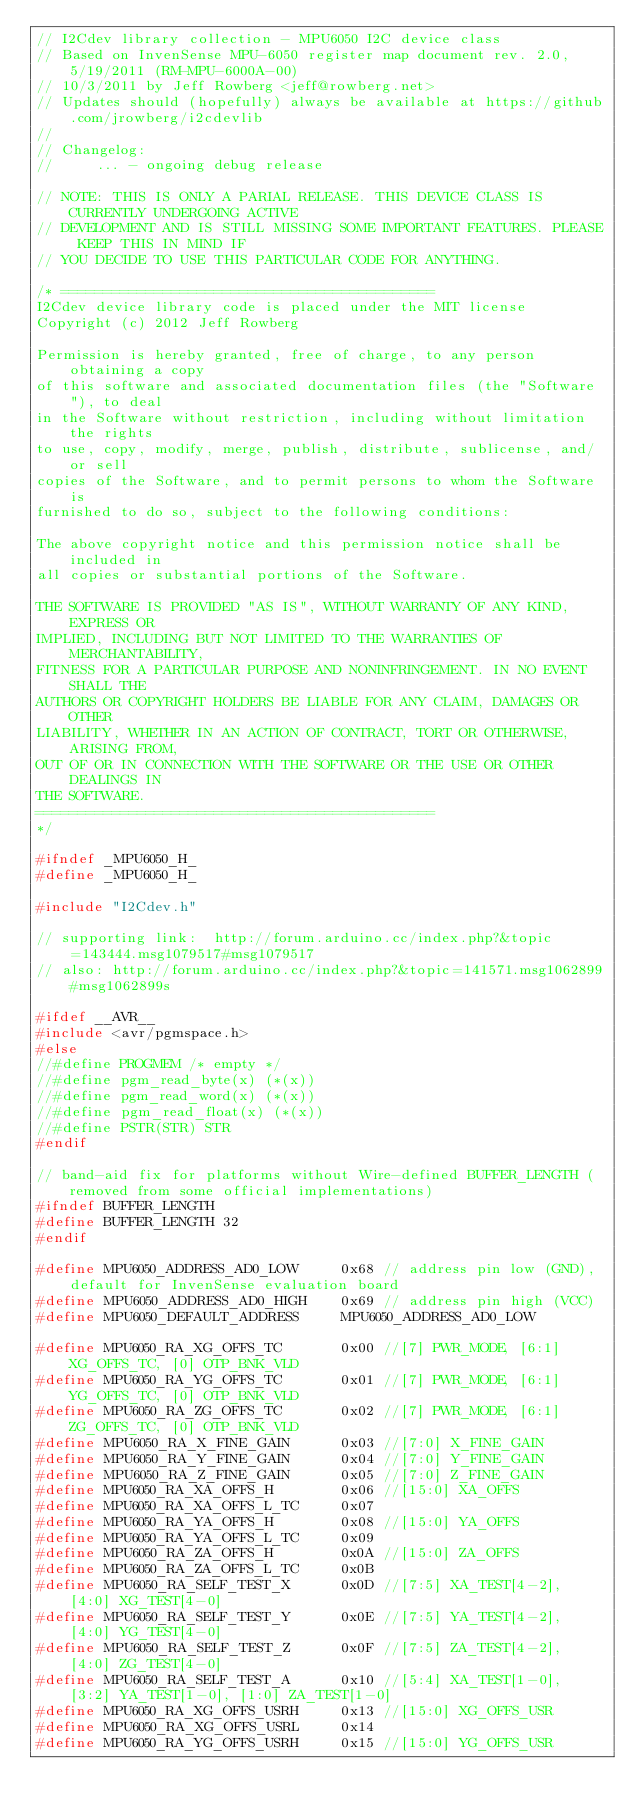<code> <loc_0><loc_0><loc_500><loc_500><_C_>// I2Cdev library collection - MPU6050 I2C device class
// Based on InvenSense MPU-6050 register map document rev. 2.0, 5/19/2011 (RM-MPU-6000A-00)
// 10/3/2011 by Jeff Rowberg <jeff@rowberg.net>
// Updates should (hopefully) always be available at https://github.com/jrowberg/i2cdevlib
//
// Changelog:
//     ... - ongoing debug release

// NOTE: THIS IS ONLY A PARIAL RELEASE. THIS DEVICE CLASS IS CURRENTLY UNDERGOING ACTIVE
// DEVELOPMENT AND IS STILL MISSING SOME IMPORTANT FEATURES. PLEASE KEEP THIS IN MIND IF
// YOU DECIDE TO USE THIS PARTICULAR CODE FOR ANYTHING.

/* ============================================
I2Cdev device library code is placed under the MIT license
Copyright (c) 2012 Jeff Rowberg

Permission is hereby granted, free of charge, to any person obtaining a copy
of this software and associated documentation files (the "Software"), to deal
in the Software without restriction, including without limitation the rights
to use, copy, modify, merge, publish, distribute, sublicense, and/or sell
copies of the Software, and to permit persons to whom the Software is
furnished to do so, subject to the following conditions:

The above copyright notice and this permission notice shall be included in
all copies or substantial portions of the Software.

THE SOFTWARE IS PROVIDED "AS IS", WITHOUT WARRANTY OF ANY KIND, EXPRESS OR
IMPLIED, INCLUDING BUT NOT LIMITED TO THE WARRANTIES OF MERCHANTABILITY,
FITNESS FOR A PARTICULAR PURPOSE AND NONINFRINGEMENT. IN NO EVENT SHALL THE
AUTHORS OR COPYRIGHT HOLDERS BE LIABLE FOR ANY CLAIM, DAMAGES OR OTHER
LIABILITY, WHETHER IN AN ACTION OF CONTRACT, TORT OR OTHERWISE, ARISING FROM,
OUT OF OR IN CONNECTION WITH THE SOFTWARE OR THE USE OR OTHER DEALINGS IN
THE SOFTWARE.
===============================================
*/

#ifndef _MPU6050_H_
#define _MPU6050_H_

#include "I2Cdev.h"

// supporting link:  http://forum.arduino.cc/index.php?&topic=143444.msg1079517#msg1079517
// also: http://forum.arduino.cc/index.php?&topic=141571.msg1062899#msg1062899s

#ifdef __AVR__
#include <avr/pgmspace.h>
#else
//#define PROGMEM /* empty */
//#define pgm_read_byte(x) (*(x))
//#define pgm_read_word(x) (*(x))
//#define pgm_read_float(x) (*(x))
//#define PSTR(STR) STR
#endif

// band-aid fix for platforms without Wire-defined BUFFER_LENGTH (removed from some official implementations)
#ifndef BUFFER_LENGTH
#define BUFFER_LENGTH 32
#endif

#define MPU6050_ADDRESS_AD0_LOW     0x68 // address pin low (GND), default for InvenSense evaluation board
#define MPU6050_ADDRESS_AD0_HIGH    0x69 // address pin high (VCC)
#define MPU6050_DEFAULT_ADDRESS     MPU6050_ADDRESS_AD0_LOW

#define MPU6050_RA_XG_OFFS_TC       0x00 //[7] PWR_MODE, [6:1] XG_OFFS_TC, [0] OTP_BNK_VLD
#define MPU6050_RA_YG_OFFS_TC       0x01 //[7] PWR_MODE, [6:1] YG_OFFS_TC, [0] OTP_BNK_VLD
#define MPU6050_RA_ZG_OFFS_TC       0x02 //[7] PWR_MODE, [6:1] ZG_OFFS_TC, [0] OTP_BNK_VLD
#define MPU6050_RA_X_FINE_GAIN      0x03 //[7:0] X_FINE_GAIN
#define MPU6050_RA_Y_FINE_GAIN      0x04 //[7:0] Y_FINE_GAIN
#define MPU6050_RA_Z_FINE_GAIN      0x05 //[7:0] Z_FINE_GAIN
#define MPU6050_RA_XA_OFFS_H        0x06 //[15:0] XA_OFFS
#define MPU6050_RA_XA_OFFS_L_TC     0x07
#define MPU6050_RA_YA_OFFS_H        0x08 //[15:0] YA_OFFS
#define MPU6050_RA_YA_OFFS_L_TC     0x09
#define MPU6050_RA_ZA_OFFS_H        0x0A //[15:0] ZA_OFFS
#define MPU6050_RA_ZA_OFFS_L_TC     0x0B
#define MPU6050_RA_SELF_TEST_X      0x0D //[7:5] XA_TEST[4-2], [4:0] XG_TEST[4-0]
#define MPU6050_RA_SELF_TEST_Y      0x0E //[7:5] YA_TEST[4-2], [4:0] YG_TEST[4-0]
#define MPU6050_RA_SELF_TEST_Z      0x0F //[7:5] ZA_TEST[4-2], [4:0] ZG_TEST[4-0]
#define MPU6050_RA_SELF_TEST_A      0x10 //[5:4] XA_TEST[1-0], [3:2] YA_TEST[1-0], [1:0] ZA_TEST[1-0]
#define MPU6050_RA_XG_OFFS_USRH     0x13 //[15:0] XG_OFFS_USR
#define MPU6050_RA_XG_OFFS_USRL     0x14
#define MPU6050_RA_YG_OFFS_USRH     0x15 //[15:0] YG_OFFS_USR</code> 